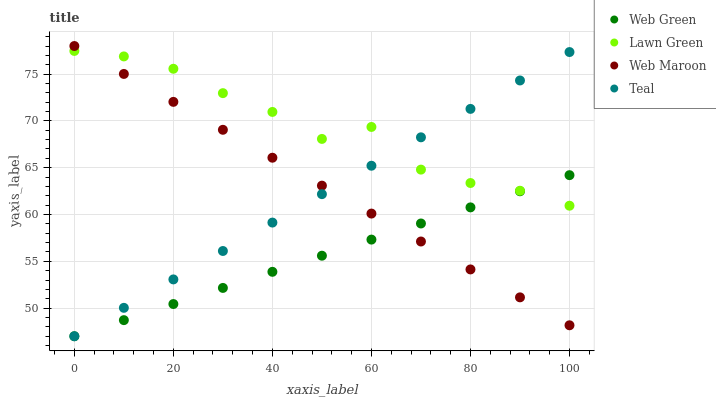Does Web Green have the minimum area under the curve?
Answer yes or no. Yes. Does Lawn Green have the maximum area under the curve?
Answer yes or no. Yes. Does Web Maroon have the minimum area under the curve?
Answer yes or no. No. Does Web Maroon have the maximum area under the curve?
Answer yes or no. No. Is Web Maroon the smoothest?
Answer yes or no. Yes. Is Lawn Green the roughest?
Answer yes or no. Yes. Is Teal the smoothest?
Answer yes or no. No. Is Teal the roughest?
Answer yes or no. No. Does Teal have the lowest value?
Answer yes or no. Yes. Does Web Maroon have the lowest value?
Answer yes or no. No. Does Web Maroon have the highest value?
Answer yes or no. Yes. Does Teal have the highest value?
Answer yes or no. No. Does Teal intersect Lawn Green?
Answer yes or no. Yes. Is Teal less than Lawn Green?
Answer yes or no. No. Is Teal greater than Lawn Green?
Answer yes or no. No. 